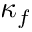Convert formula to latex. <formula><loc_0><loc_0><loc_500><loc_500>\kappa _ { f }</formula> 